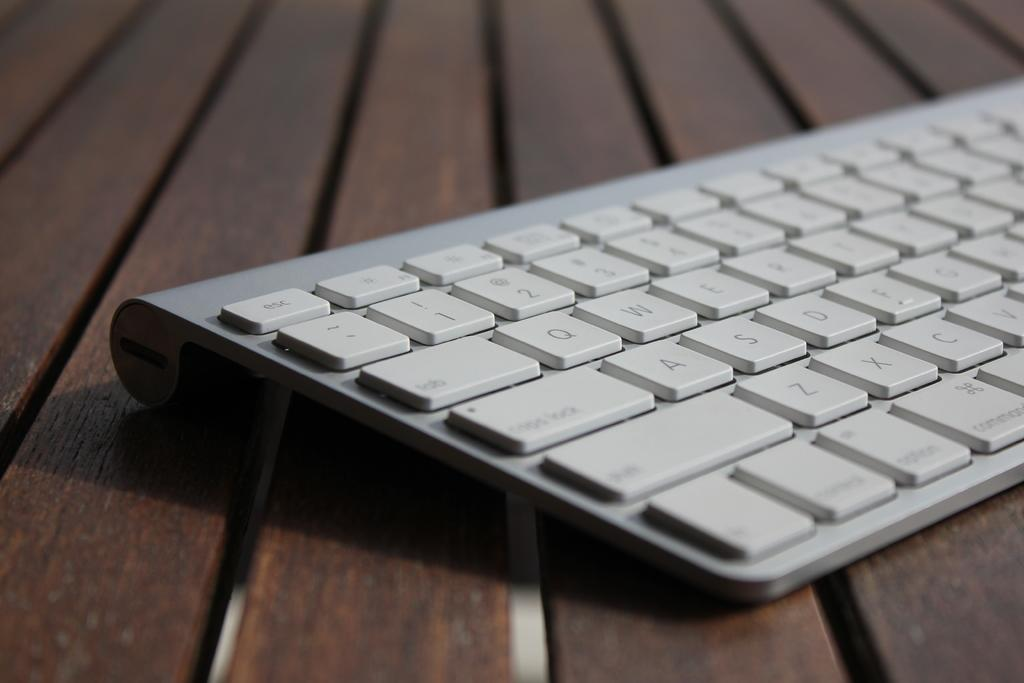<image>
Present a compact description of the photo's key features. A close up of a sliver keyboard from the capslock side. 